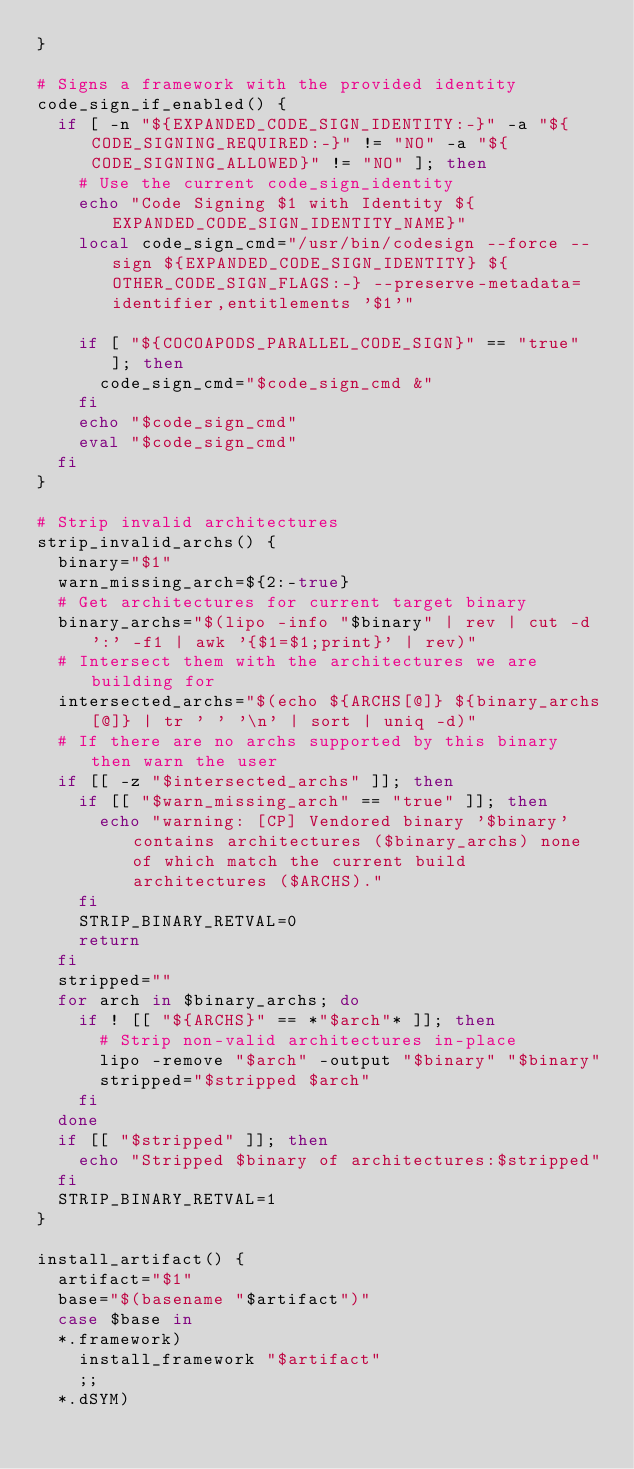<code> <loc_0><loc_0><loc_500><loc_500><_Bash_>}

# Signs a framework with the provided identity
code_sign_if_enabled() {
  if [ -n "${EXPANDED_CODE_SIGN_IDENTITY:-}" -a "${CODE_SIGNING_REQUIRED:-}" != "NO" -a "${CODE_SIGNING_ALLOWED}" != "NO" ]; then
    # Use the current code_sign_identity
    echo "Code Signing $1 with Identity ${EXPANDED_CODE_SIGN_IDENTITY_NAME}"
    local code_sign_cmd="/usr/bin/codesign --force --sign ${EXPANDED_CODE_SIGN_IDENTITY} ${OTHER_CODE_SIGN_FLAGS:-} --preserve-metadata=identifier,entitlements '$1'"

    if [ "${COCOAPODS_PARALLEL_CODE_SIGN}" == "true" ]; then
      code_sign_cmd="$code_sign_cmd &"
    fi
    echo "$code_sign_cmd"
    eval "$code_sign_cmd"
  fi
}

# Strip invalid architectures
strip_invalid_archs() {
  binary="$1"
  warn_missing_arch=${2:-true}
  # Get architectures for current target binary
  binary_archs="$(lipo -info "$binary" | rev | cut -d ':' -f1 | awk '{$1=$1;print}' | rev)"
  # Intersect them with the architectures we are building for
  intersected_archs="$(echo ${ARCHS[@]} ${binary_archs[@]} | tr ' ' '\n' | sort | uniq -d)"
  # If there are no archs supported by this binary then warn the user
  if [[ -z "$intersected_archs" ]]; then
    if [[ "$warn_missing_arch" == "true" ]]; then
      echo "warning: [CP] Vendored binary '$binary' contains architectures ($binary_archs) none of which match the current build architectures ($ARCHS)."
    fi
    STRIP_BINARY_RETVAL=0
    return
  fi
  stripped=""
  for arch in $binary_archs; do
    if ! [[ "${ARCHS}" == *"$arch"* ]]; then
      # Strip non-valid architectures in-place
      lipo -remove "$arch" -output "$binary" "$binary"
      stripped="$stripped $arch"
    fi
  done
  if [[ "$stripped" ]]; then
    echo "Stripped $binary of architectures:$stripped"
  fi
  STRIP_BINARY_RETVAL=1
}

install_artifact() {
  artifact="$1"
  base="$(basename "$artifact")"
  case $base in
  *.framework)
    install_framework "$artifact"
    ;;
  *.dSYM)</code> 